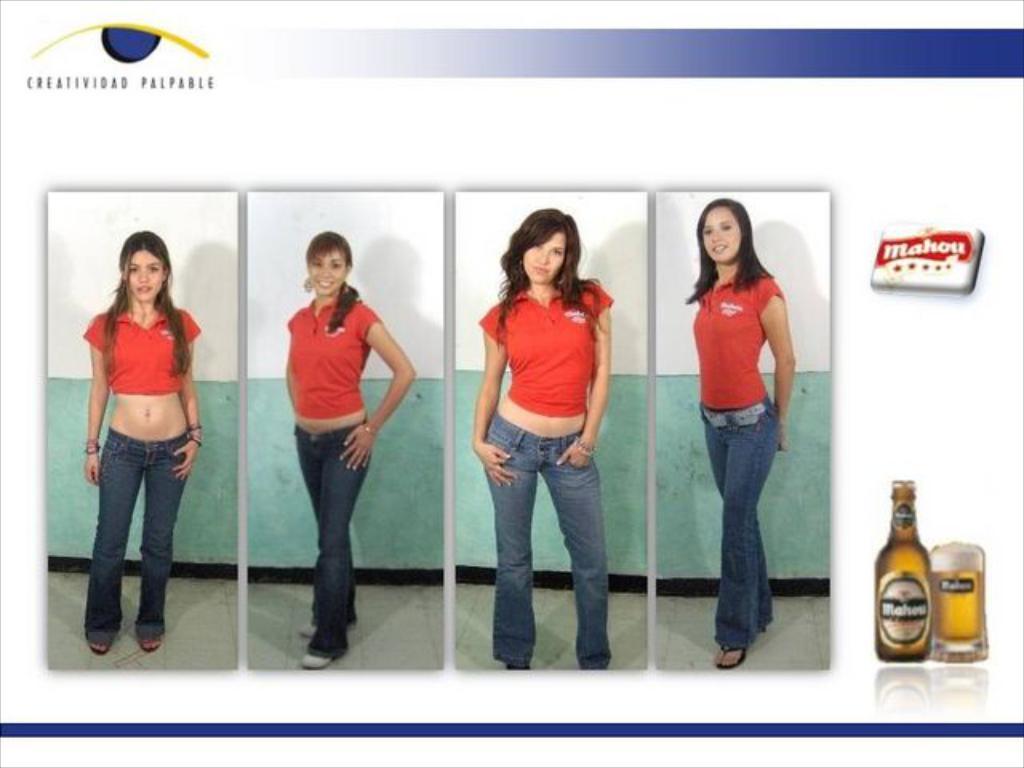Describe this image in one or two sentences. This is an edited image. In this image we can see some woman standing on the floor. We can also see the picture of a bottle and a glass with beer, a logo and some text. 